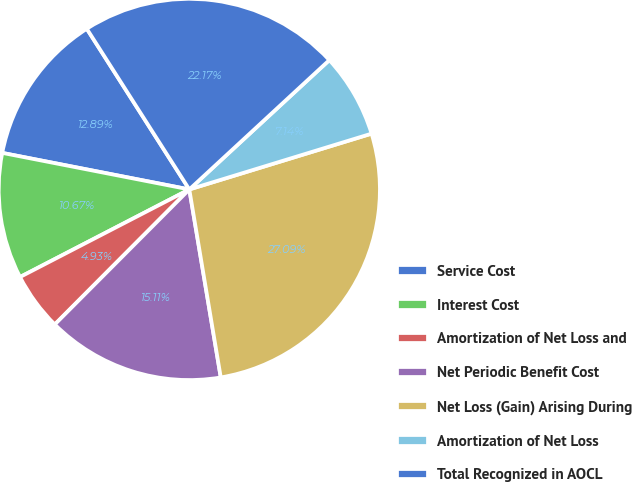Convert chart to OTSL. <chart><loc_0><loc_0><loc_500><loc_500><pie_chart><fcel>Service Cost<fcel>Interest Cost<fcel>Amortization of Net Loss and<fcel>Net Periodic Benefit Cost<fcel>Net Loss (Gain) Arising During<fcel>Amortization of Net Loss<fcel>Total Recognized in AOCL<nl><fcel>12.89%<fcel>10.67%<fcel>4.93%<fcel>15.11%<fcel>27.09%<fcel>7.14%<fcel>22.17%<nl></chart> 